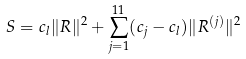<formula> <loc_0><loc_0><loc_500><loc_500>S = c _ { l } \| R \| ^ { 2 } + \sum _ { j = 1 } ^ { 1 1 } ( c _ { j } - c _ { l } ) \| R ^ { ( j ) } \| ^ { 2 }</formula> 